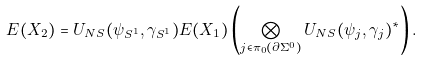Convert formula to latex. <formula><loc_0><loc_0><loc_500><loc_500>E ( X _ { 2 } ) = U _ { N S } ( \psi _ { S ^ { 1 } } , \gamma _ { S ^ { 1 } } ) E ( X _ { 1 } ) \left ( \bigotimes _ { j \in \pi _ { 0 } ( \partial \Sigma ^ { 0 } ) } U _ { N S } ( \psi _ { j } , \gamma _ { j } ) ^ { * } \right ) .</formula> 